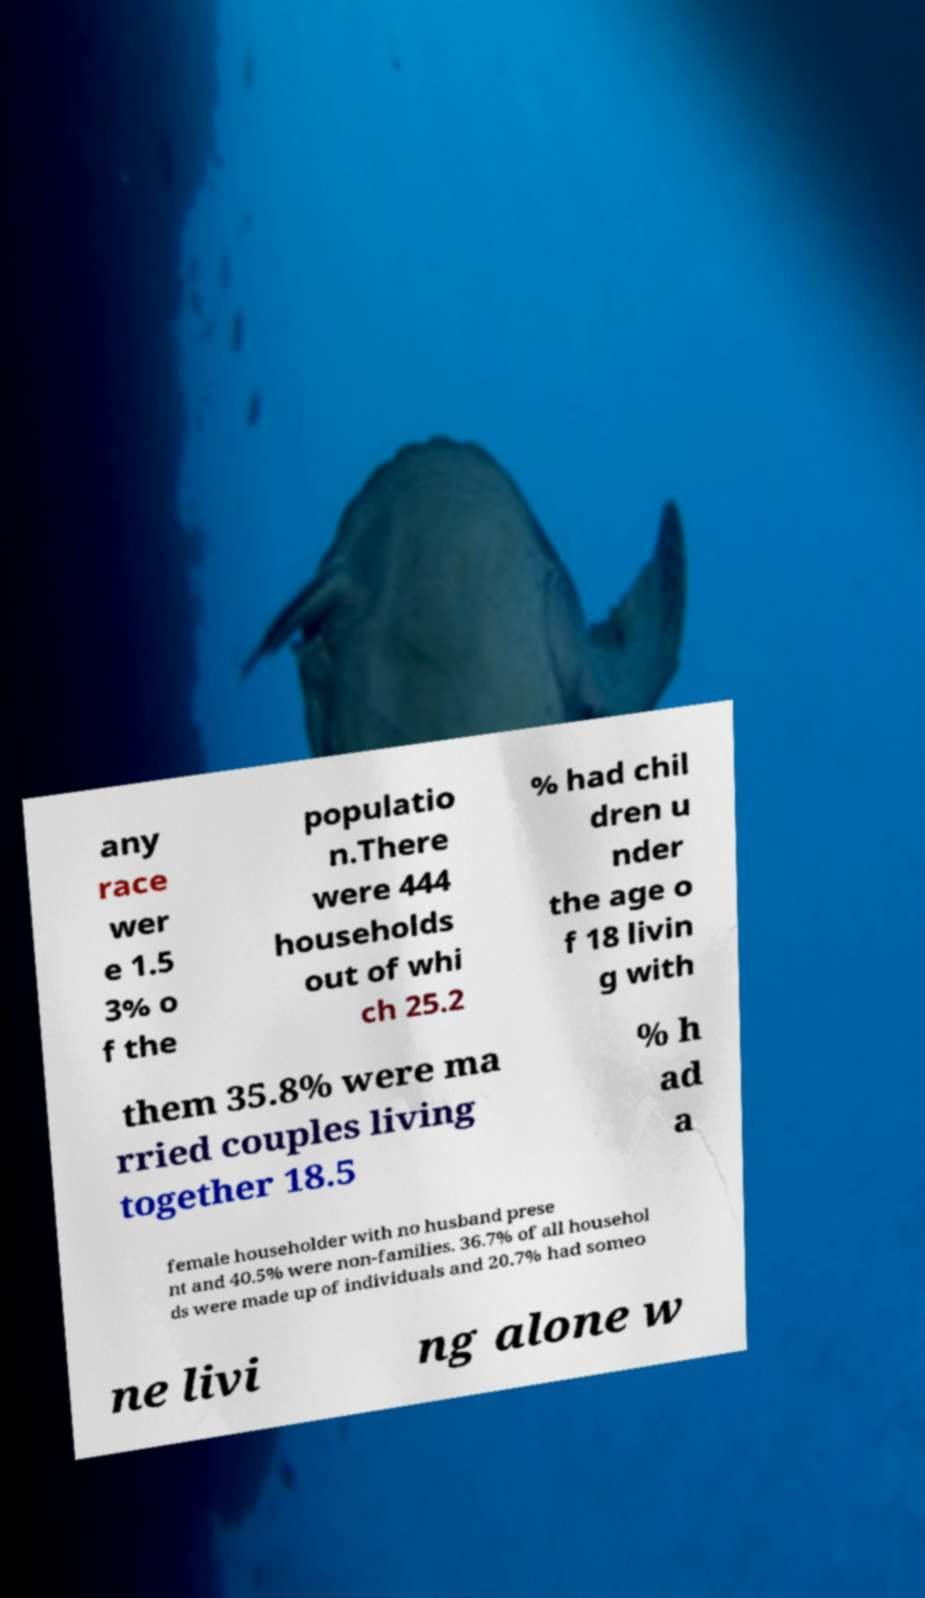Can you read and provide the text displayed in the image?This photo seems to have some interesting text. Can you extract and type it out for me? any race wer e 1.5 3% o f the populatio n.There were 444 households out of whi ch 25.2 % had chil dren u nder the age o f 18 livin g with them 35.8% were ma rried couples living together 18.5 % h ad a female householder with no husband prese nt and 40.5% were non-families. 36.7% of all househol ds were made up of individuals and 20.7% had someo ne livi ng alone w 